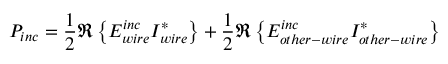<formula> <loc_0><loc_0><loc_500><loc_500>P _ { i n c } = \frac { 1 } { 2 } \Re \left \{ E _ { w i r e } ^ { i n c } I _ { w i r e } ^ { * } \right \} + \frac { 1 } { 2 } \Re \left \{ E _ { o t h e r - w i r e } ^ { i n c } I _ { o t h e r - w i r e } ^ { * } \right \}</formula> 